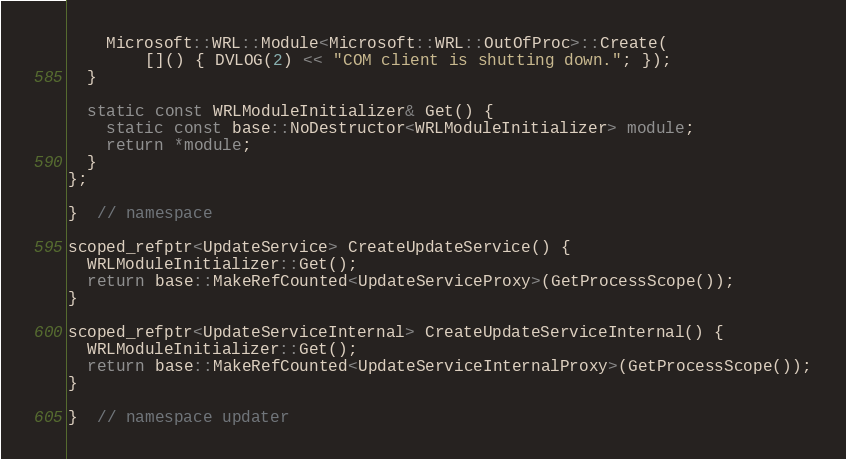<code> <loc_0><loc_0><loc_500><loc_500><_C++_>    Microsoft::WRL::Module<Microsoft::WRL::OutOfProc>::Create(
        []() { DVLOG(2) << "COM client is shutting down."; });
  }

  static const WRLModuleInitializer& Get() {
    static const base::NoDestructor<WRLModuleInitializer> module;
    return *module;
  }
};

}  // namespace

scoped_refptr<UpdateService> CreateUpdateService() {
  WRLModuleInitializer::Get();
  return base::MakeRefCounted<UpdateServiceProxy>(GetProcessScope());
}

scoped_refptr<UpdateServiceInternal> CreateUpdateServiceInternal() {
  WRLModuleInitializer::Get();
  return base::MakeRefCounted<UpdateServiceInternalProxy>(GetProcessScope());
}

}  // namespace updater
</code> 